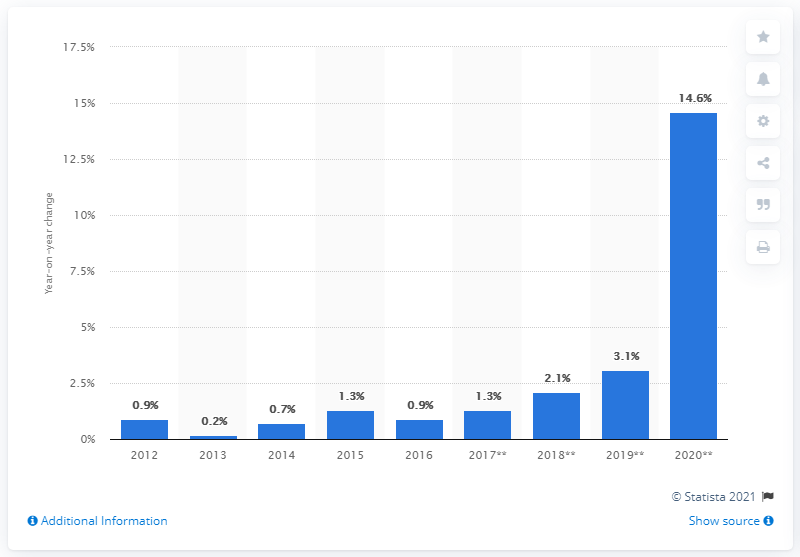Draw attention to some important aspects in this diagram. According to the data, retail sales of supermarkets and other grocery stores in Canada increased by 14.6% in December 2020 compared to December 2019. 